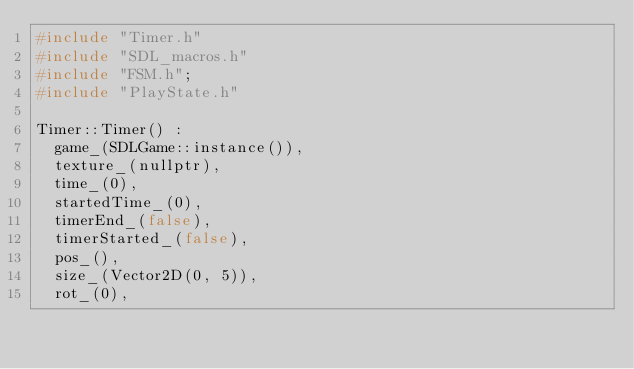<code> <loc_0><loc_0><loc_500><loc_500><_C++_>#include "Timer.h"
#include "SDL_macros.h"
#include "FSM.h";
#include "PlayState.h"

Timer::Timer() :
	game_(SDLGame::instance()),
	texture_(nullptr),
	time_(0),
	startedTime_(0),
	timerEnd_(false),
	timerStarted_(false),
	pos_(),
	size_(Vector2D(0, 5)),
	rot_(0),</code> 